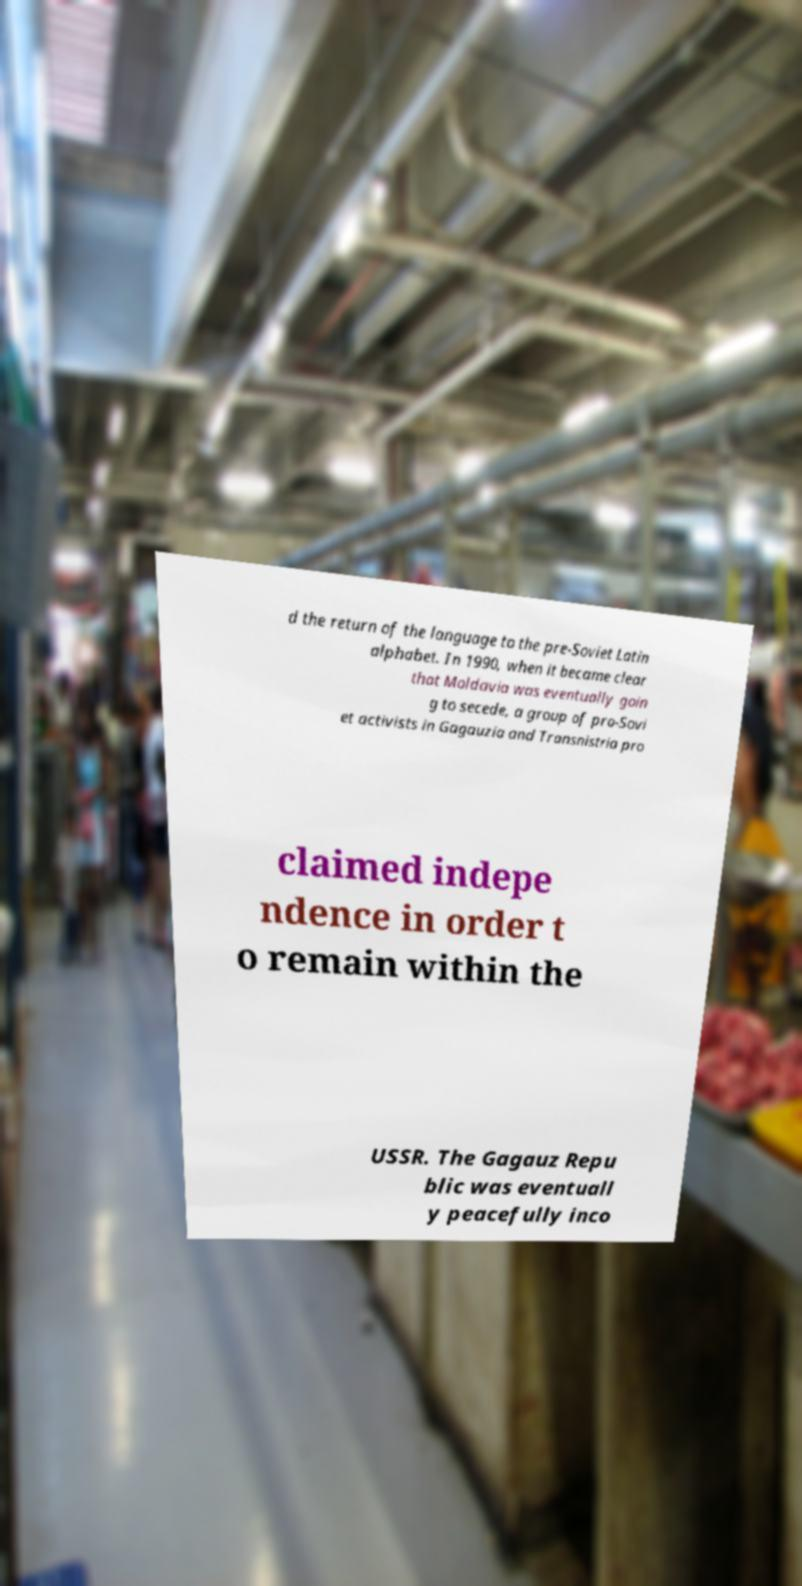What messages or text are displayed in this image? I need them in a readable, typed format. d the return of the language to the pre-Soviet Latin alphabet. In 1990, when it became clear that Moldavia was eventually goin g to secede, a group of pro-Sovi et activists in Gagauzia and Transnistria pro claimed indepe ndence in order t o remain within the USSR. The Gagauz Repu blic was eventuall y peacefully inco 